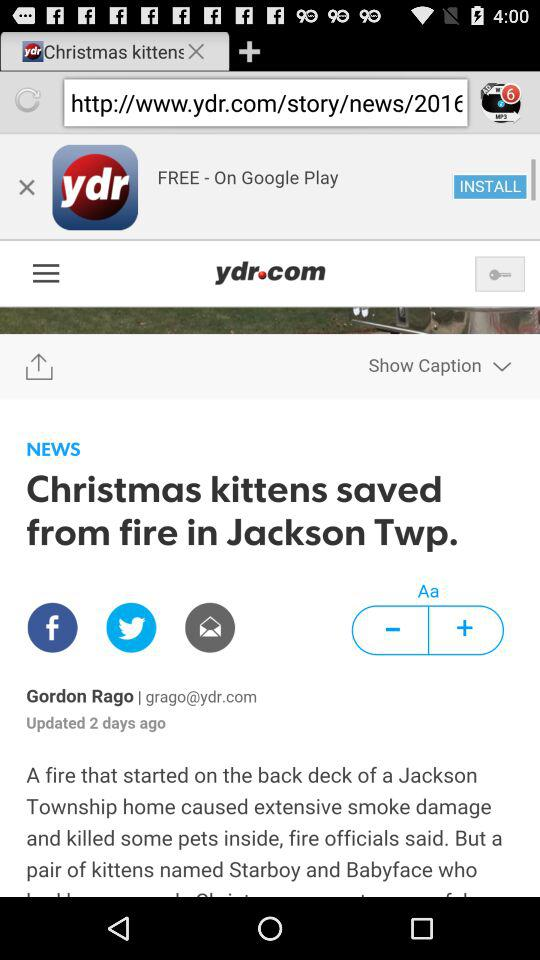Through which application can the user share the news? The user can share the news through the applications "Facebook" and "Twitter". 